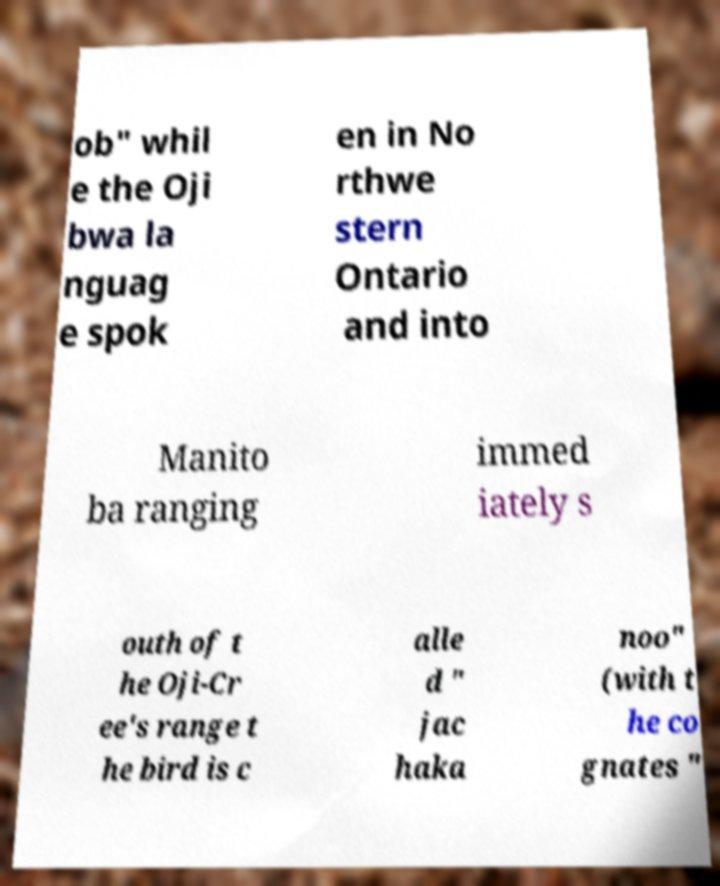Can you accurately transcribe the text from the provided image for me? ob" whil e the Oji bwa la nguag e spok en in No rthwe stern Ontario and into Manito ba ranging immed iately s outh of t he Oji-Cr ee's range t he bird is c alle d " jac haka noo" (with t he co gnates " 